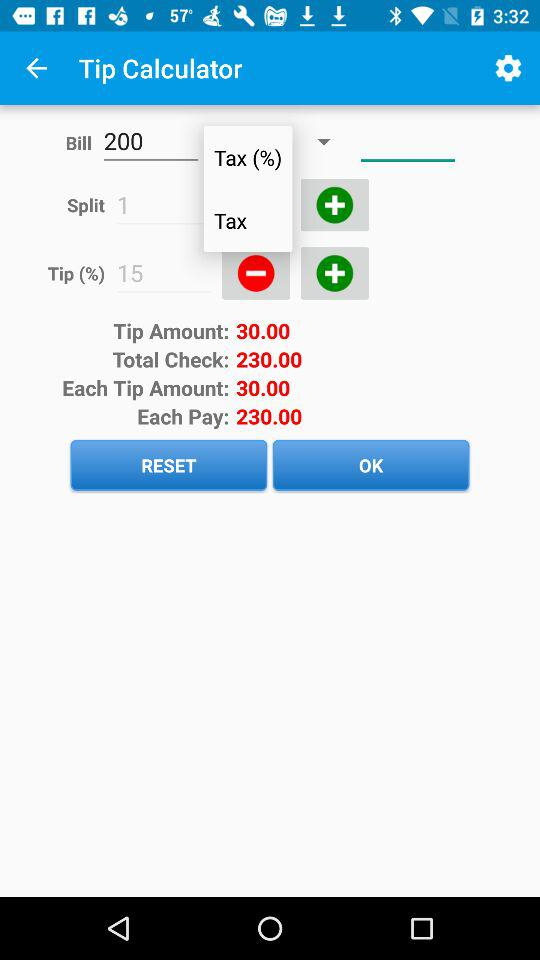What is the amount for each tip? The amount for each tip is 30.00. 